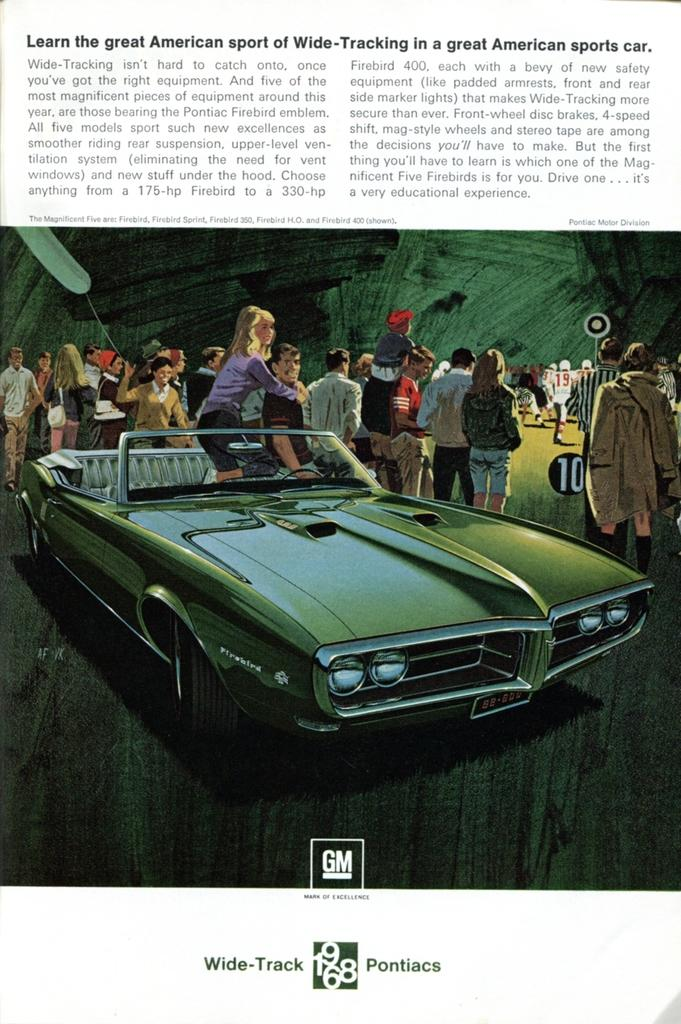What type of image is present in the picture? There is a graphical image in the picture. What else can be seen in the picture besides the image? There is a car and people standing in the picture. Where is the text located in the picture? There is text at the top and bottom of the picture. How deep is the hole in the picture? There is no hole present in the picture. What type of respect is shown by the people in the picture? There is no indication of respect being shown by the people in the picture. 